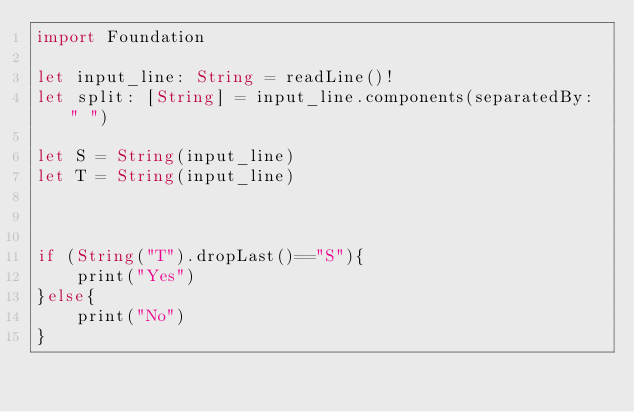<code> <loc_0><loc_0><loc_500><loc_500><_Swift_>import Foundation
 
let input_line: String = readLine()!
let split: [String] = input_line.components(separatedBy: " ")
 
let S = String(input_line)
let T = String(input_line)



if (String("T").dropLast()=="S"){
    print("Yes")
}else{
    print("No")
}

</code> 